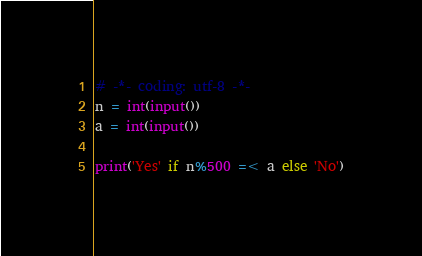Convert code to text. <code><loc_0><loc_0><loc_500><loc_500><_Python_># -*- coding: utf-8 -*-
n = int(input())
a = int(input())

print('Yes' if n%500 =< a else 'No')</code> 